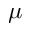Convert formula to latex. <formula><loc_0><loc_0><loc_500><loc_500>\mu</formula> 